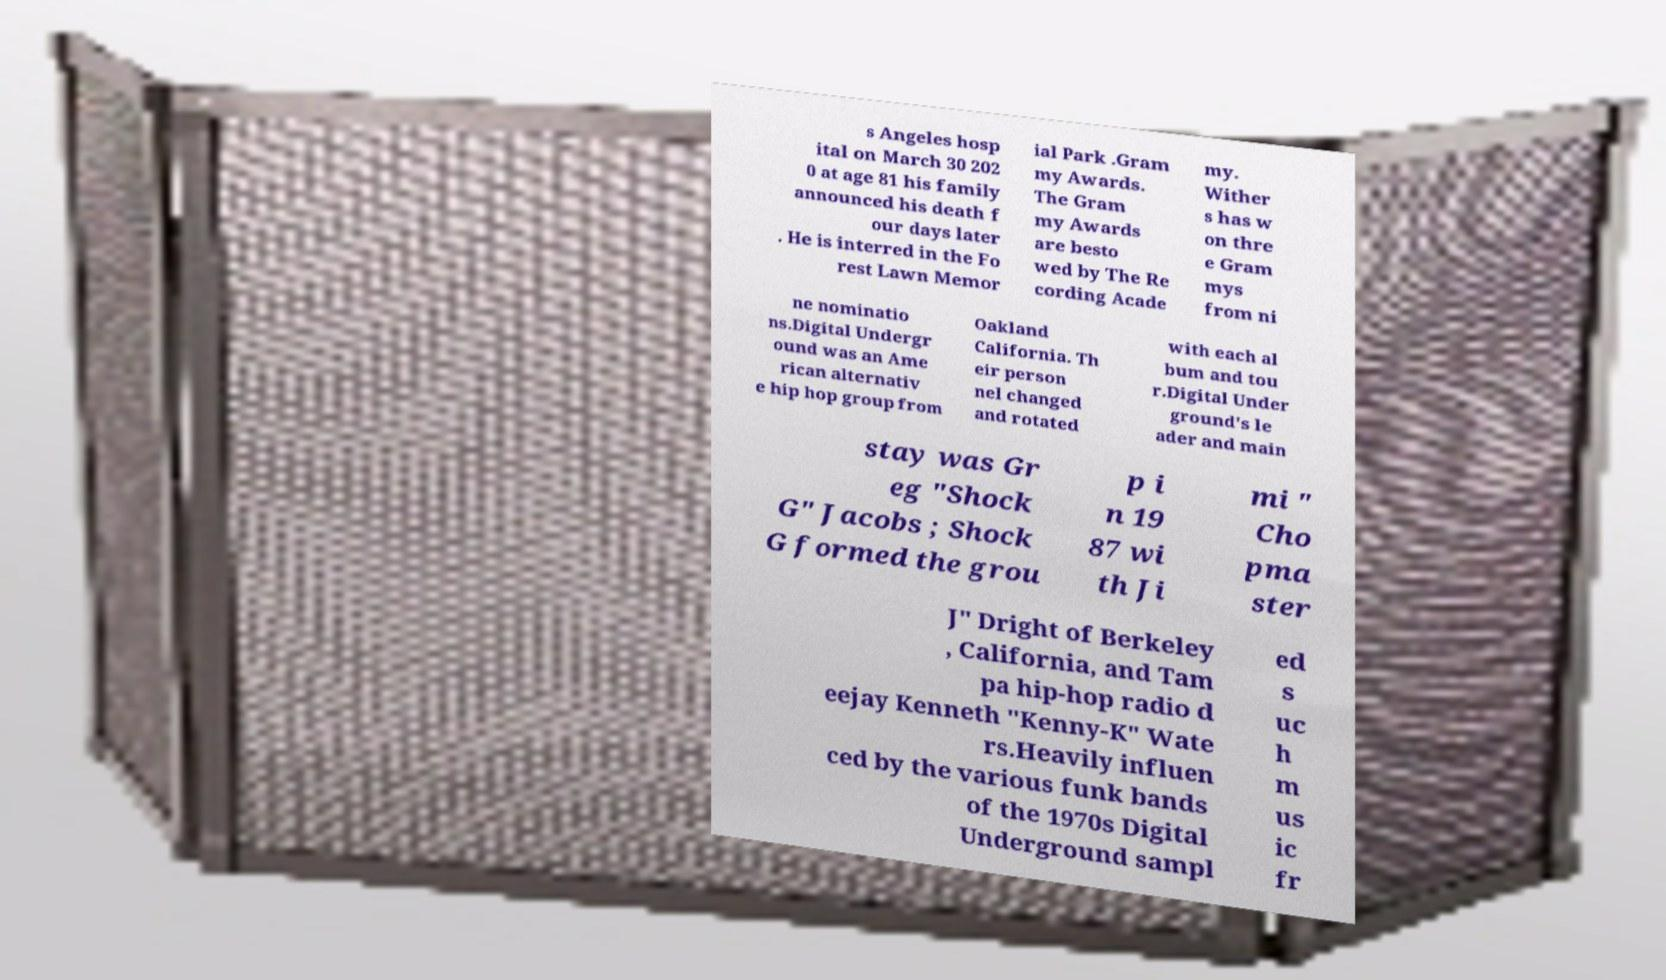Could you assist in decoding the text presented in this image and type it out clearly? s Angeles hosp ital on March 30 202 0 at age 81 his family announced his death f our days later . He is interred in the Fo rest Lawn Memor ial Park .Gram my Awards. The Gram my Awards are besto wed by The Re cording Acade my. Wither s has w on thre e Gram mys from ni ne nominatio ns.Digital Undergr ound was an Ame rican alternativ e hip hop group from Oakland California. Th eir person nel changed and rotated with each al bum and tou r.Digital Under ground's le ader and main stay was Gr eg "Shock G" Jacobs ; Shock G formed the grou p i n 19 87 wi th Ji mi " Cho pma ster J" Dright of Berkeley , California, and Tam pa hip-hop radio d eejay Kenneth "Kenny-K" Wate rs.Heavily influen ced by the various funk bands of the 1970s Digital Underground sampl ed s uc h m us ic fr 